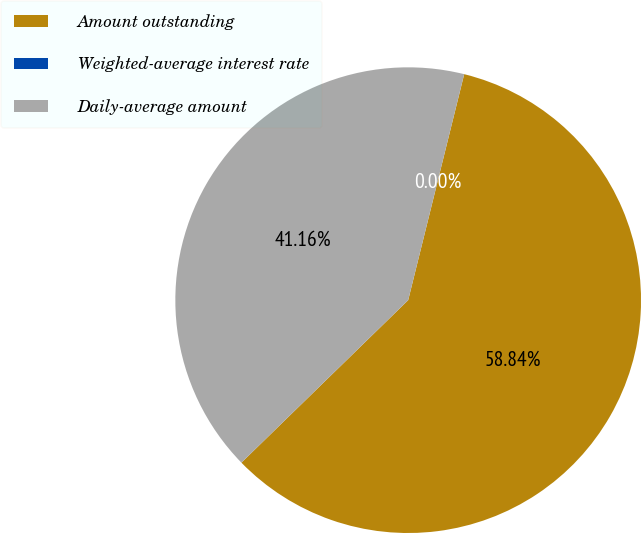Convert chart to OTSL. <chart><loc_0><loc_0><loc_500><loc_500><pie_chart><fcel>Amount outstanding<fcel>Weighted-average interest rate<fcel>Daily-average amount<nl><fcel>58.84%<fcel>0.0%<fcel>41.16%<nl></chart> 